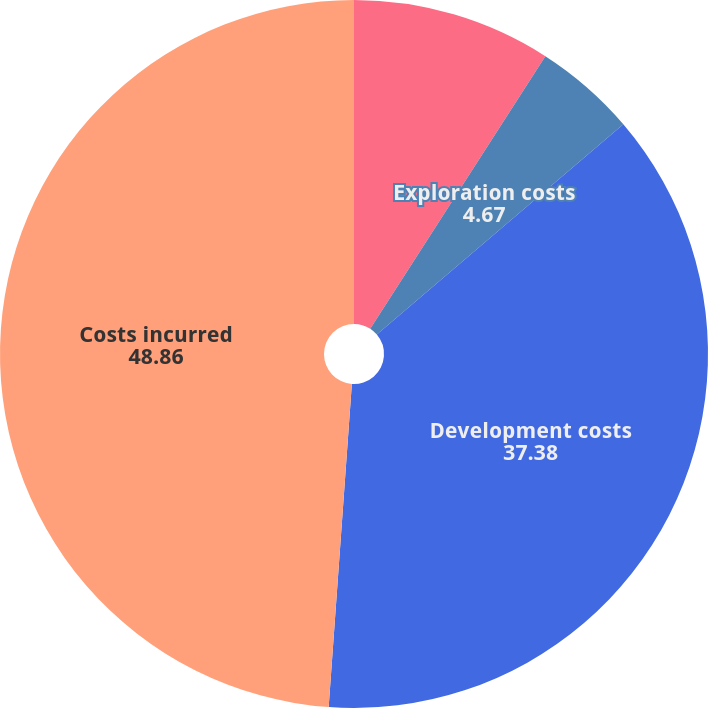Convert chart to OTSL. <chart><loc_0><loc_0><loc_500><loc_500><pie_chart><fcel>Unproved properties<fcel>Exploration costs<fcel>Development costs<fcel>Costs incurred<nl><fcel>9.09%<fcel>4.67%<fcel>37.38%<fcel>48.86%<nl></chart> 